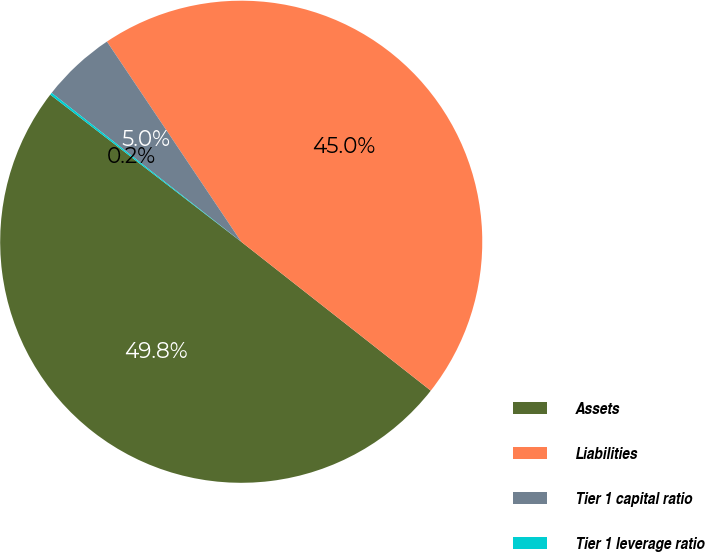Convert chart to OTSL. <chart><loc_0><loc_0><loc_500><loc_500><pie_chart><fcel>Assets<fcel>Liabilities<fcel>Tier 1 capital ratio<fcel>Tier 1 leverage ratio<nl><fcel>49.85%<fcel>45.0%<fcel>5.0%<fcel>0.15%<nl></chart> 